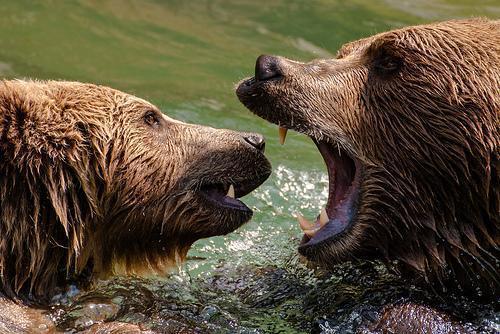How many bears?
Give a very brief answer. 2. How many teeth are seen?
Give a very brief answer. 4. 